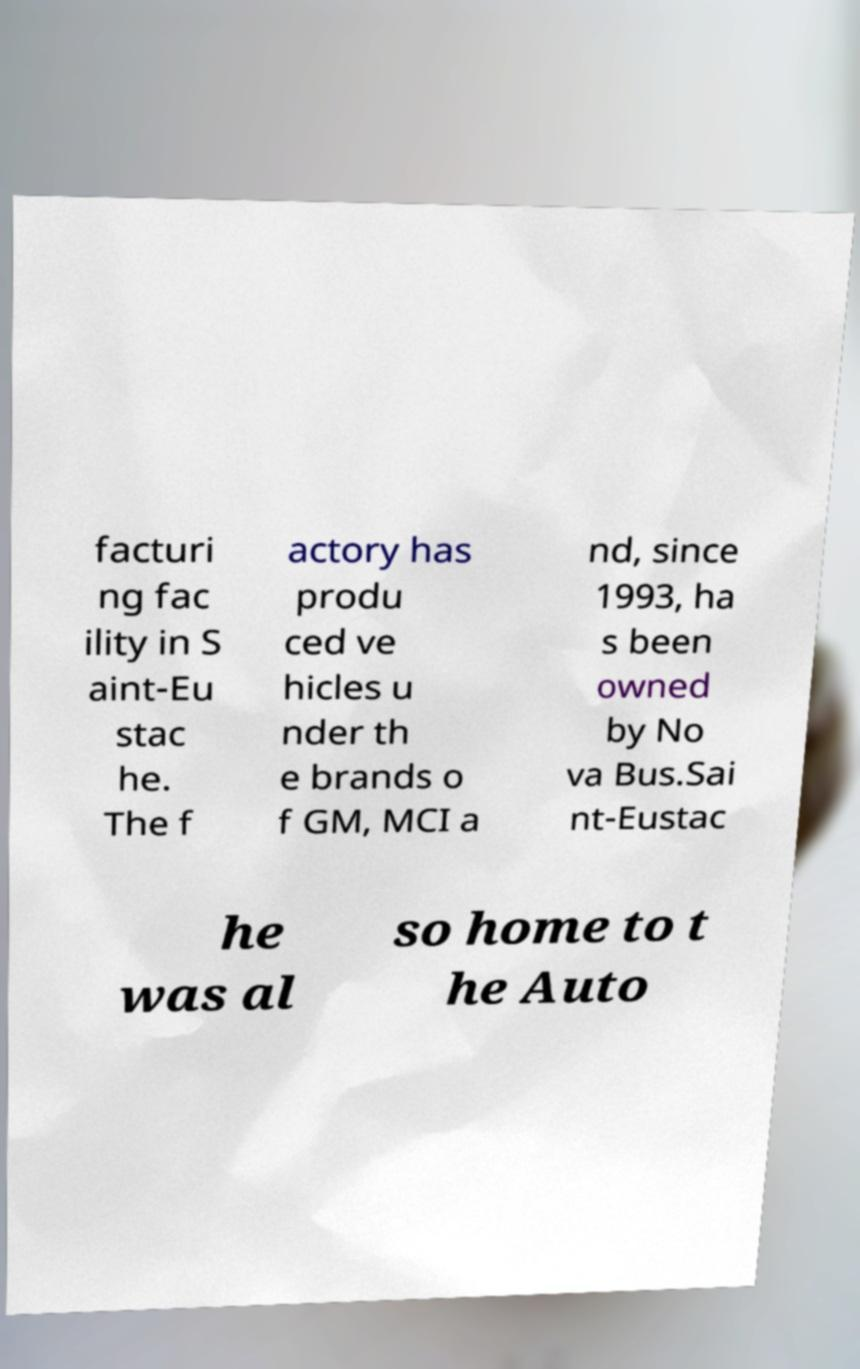Please identify and transcribe the text found in this image. facturi ng fac ility in S aint-Eu stac he. The f actory has produ ced ve hicles u nder th e brands o f GM, MCI a nd, since 1993, ha s been owned by No va Bus.Sai nt-Eustac he was al so home to t he Auto 